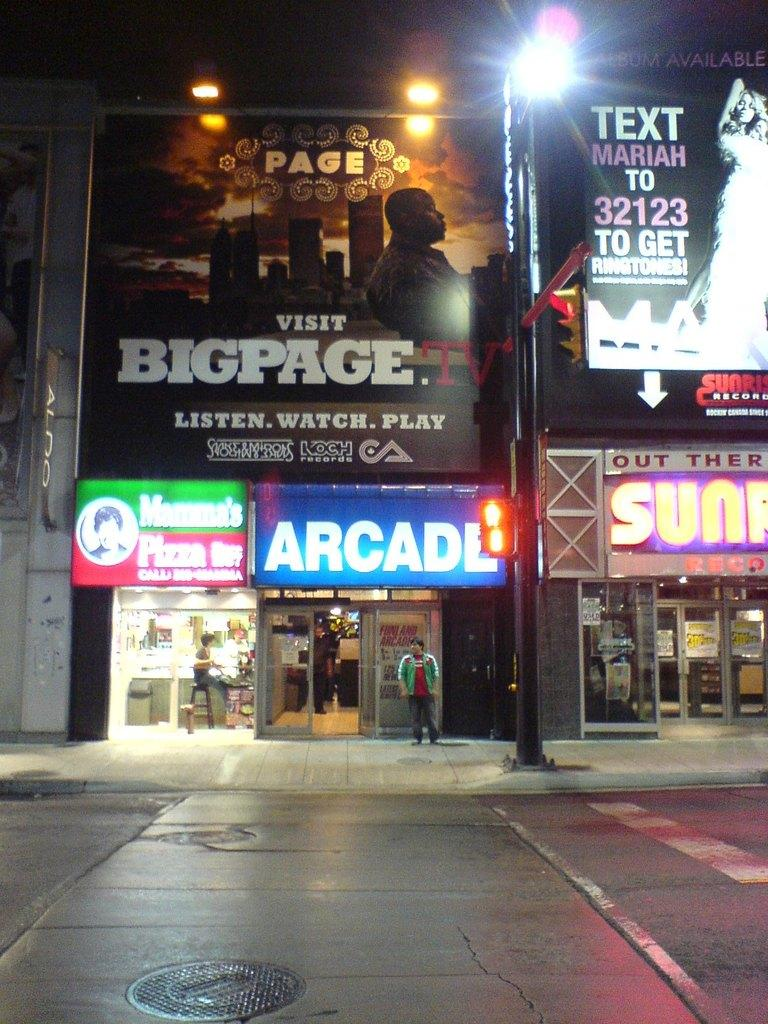Who or what can be seen in the image? There are people in the image. What can be seen in the distance behind the people? There are buildings in the background of the image. Are there any signs or markers visible in the background? Yes, name boards are present in the background of the image. What else can be observed in the background? Lights are visible in the background of the image. Can you see any mice running around in the image? There are no mice present in the image. What type of fang can be seen on the people in the image? There are no fangs present on the people in the image. 